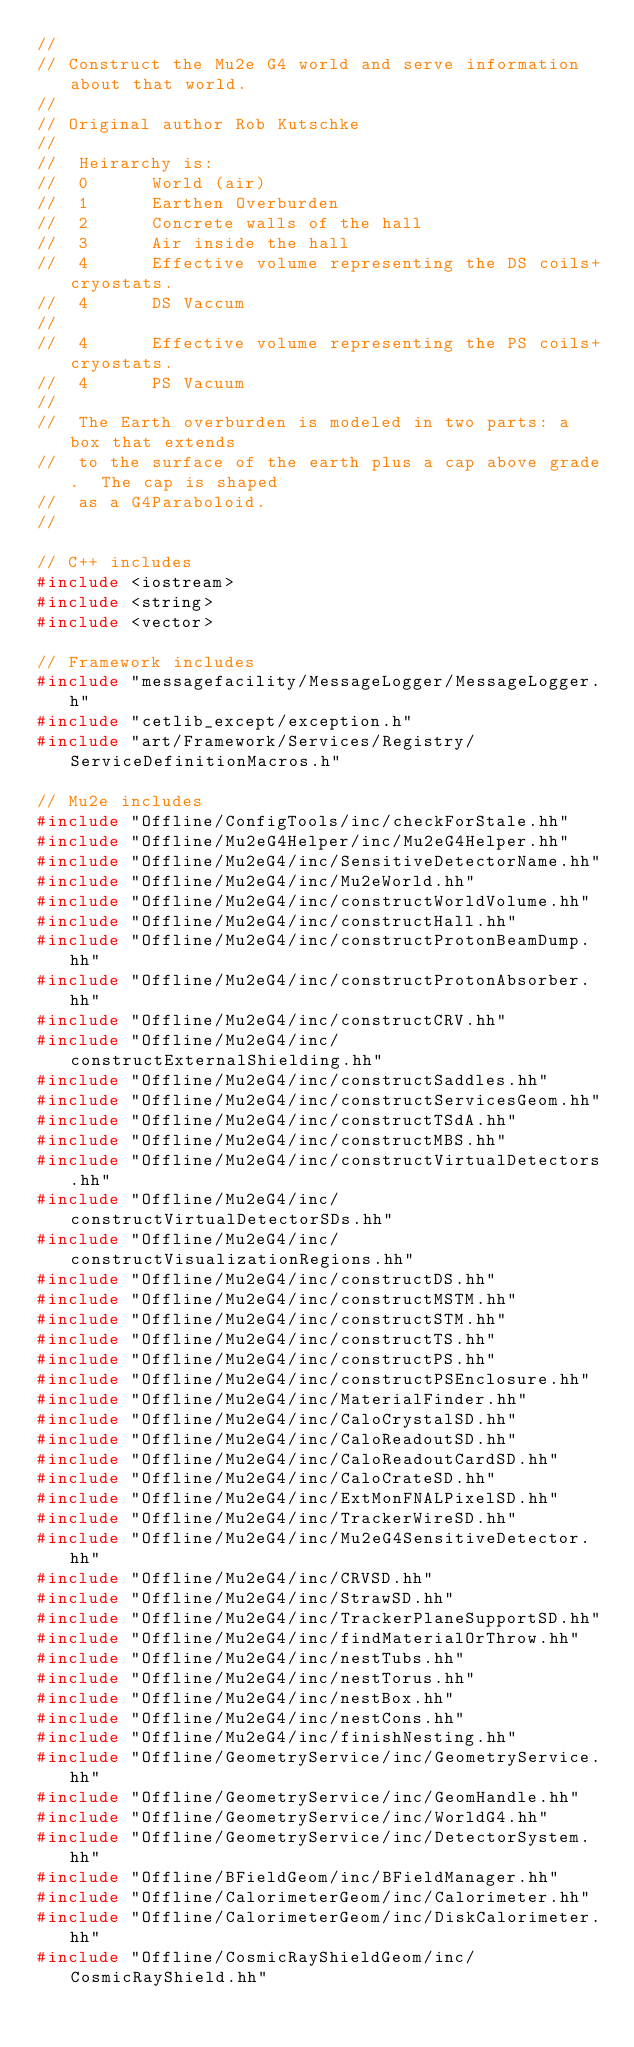<code> <loc_0><loc_0><loc_500><loc_500><_C++_>//
// Construct the Mu2e G4 world and serve information about that world.
//
// Original author Rob Kutschke
//
//  Heirarchy is:
//  0      World (air)
//  1      Earthen Overburden
//  2      Concrete walls of the hall
//  3      Air inside the hall
//  4      Effective volume representing the DS coils+cryostats.
//  4      DS Vaccum
//
//  4      Effective volume representing the PS coils+cryostats.
//  4      PS Vacuum
//
//  The Earth overburden is modeled in two parts: a box that extends
//  to the surface of the earth plus a cap above grade.  The cap is shaped
//  as a G4Paraboloid.
//

// C++ includes
#include <iostream>
#include <string>
#include <vector>

// Framework includes
#include "messagefacility/MessageLogger/MessageLogger.h"
#include "cetlib_except/exception.h"
#include "art/Framework/Services/Registry/ServiceDefinitionMacros.h"

// Mu2e includes
#include "Offline/ConfigTools/inc/checkForStale.hh"
#include "Offline/Mu2eG4Helper/inc/Mu2eG4Helper.hh"
#include "Offline/Mu2eG4/inc/SensitiveDetectorName.hh"
#include "Offline/Mu2eG4/inc/Mu2eWorld.hh"
#include "Offline/Mu2eG4/inc/constructWorldVolume.hh"
#include "Offline/Mu2eG4/inc/constructHall.hh"
#include "Offline/Mu2eG4/inc/constructProtonBeamDump.hh"
#include "Offline/Mu2eG4/inc/constructProtonAbsorber.hh"
#include "Offline/Mu2eG4/inc/constructCRV.hh"
#include "Offline/Mu2eG4/inc/constructExternalShielding.hh"
#include "Offline/Mu2eG4/inc/constructSaddles.hh"
#include "Offline/Mu2eG4/inc/constructServicesGeom.hh"
#include "Offline/Mu2eG4/inc/constructTSdA.hh"
#include "Offline/Mu2eG4/inc/constructMBS.hh"
#include "Offline/Mu2eG4/inc/constructVirtualDetectors.hh"
#include "Offline/Mu2eG4/inc/constructVirtualDetectorSDs.hh"
#include "Offline/Mu2eG4/inc/constructVisualizationRegions.hh"
#include "Offline/Mu2eG4/inc/constructDS.hh"
#include "Offline/Mu2eG4/inc/constructMSTM.hh"
#include "Offline/Mu2eG4/inc/constructSTM.hh"
#include "Offline/Mu2eG4/inc/constructTS.hh"
#include "Offline/Mu2eG4/inc/constructPS.hh"
#include "Offline/Mu2eG4/inc/constructPSEnclosure.hh"
#include "Offline/Mu2eG4/inc/MaterialFinder.hh"
#include "Offline/Mu2eG4/inc/CaloCrystalSD.hh"
#include "Offline/Mu2eG4/inc/CaloReadoutSD.hh"
#include "Offline/Mu2eG4/inc/CaloReadoutCardSD.hh"
#include "Offline/Mu2eG4/inc/CaloCrateSD.hh"
#include "Offline/Mu2eG4/inc/ExtMonFNALPixelSD.hh"
#include "Offline/Mu2eG4/inc/TrackerWireSD.hh"
#include "Offline/Mu2eG4/inc/Mu2eG4SensitiveDetector.hh"
#include "Offline/Mu2eG4/inc/CRVSD.hh"
#include "Offline/Mu2eG4/inc/StrawSD.hh"
#include "Offline/Mu2eG4/inc/TrackerPlaneSupportSD.hh"
#include "Offline/Mu2eG4/inc/findMaterialOrThrow.hh"
#include "Offline/Mu2eG4/inc/nestTubs.hh"
#include "Offline/Mu2eG4/inc/nestTorus.hh"
#include "Offline/Mu2eG4/inc/nestBox.hh"
#include "Offline/Mu2eG4/inc/nestCons.hh"
#include "Offline/Mu2eG4/inc/finishNesting.hh"
#include "Offline/GeometryService/inc/GeometryService.hh"
#include "Offline/GeometryService/inc/GeomHandle.hh"
#include "Offline/GeometryService/inc/WorldG4.hh"
#include "Offline/GeometryService/inc/DetectorSystem.hh"
#include "Offline/BFieldGeom/inc/BFieldManager.hh"
#include "Offline/CalorimeterGeom/inc/Calorimeter.hh"
#include "Offline/CalorimeterGeom/inc/DiskCalorimeter.hh"
#include "Offline/CosmicRayShieldGeom/inc/CosmicRayShield.hh"</code> 